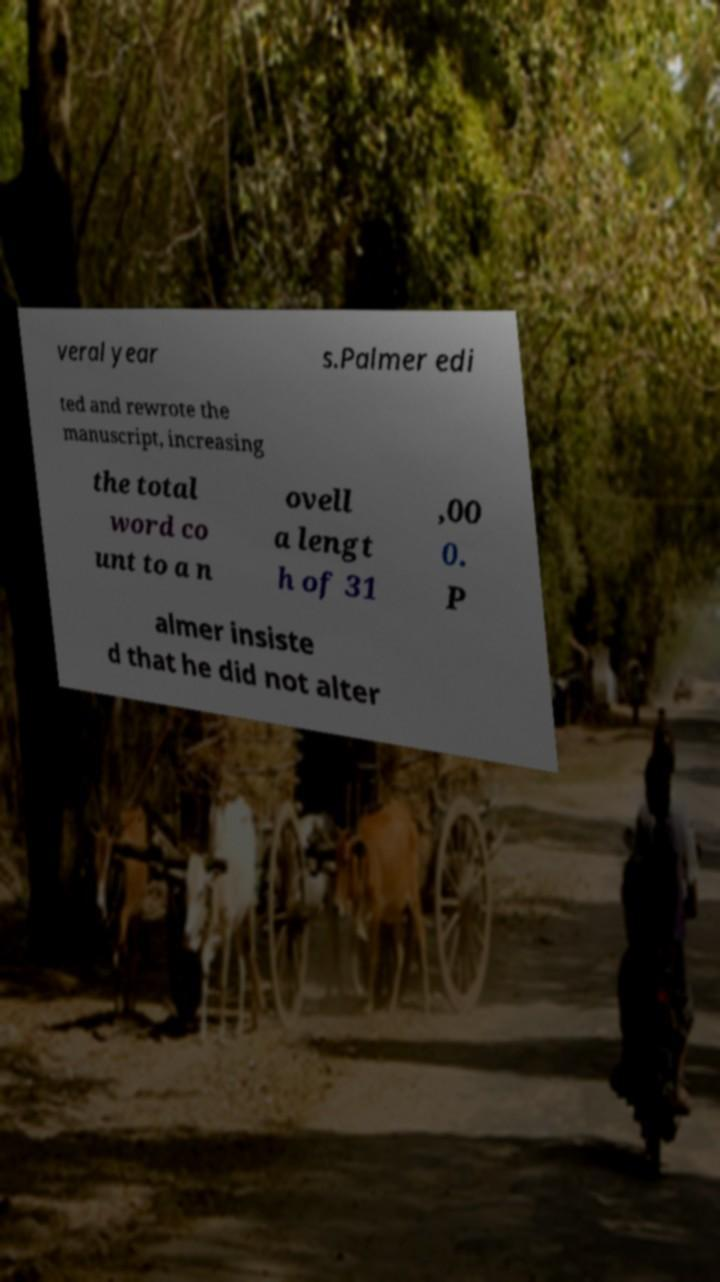Can you accurately transcribe the text from the provided image for me? veral year s.Palmer edi ted and rewrote the manuscript, increasing the total word co unt to a n ovell a lengt h of 31 ,00 0. P almer insiste d that he did not alter 